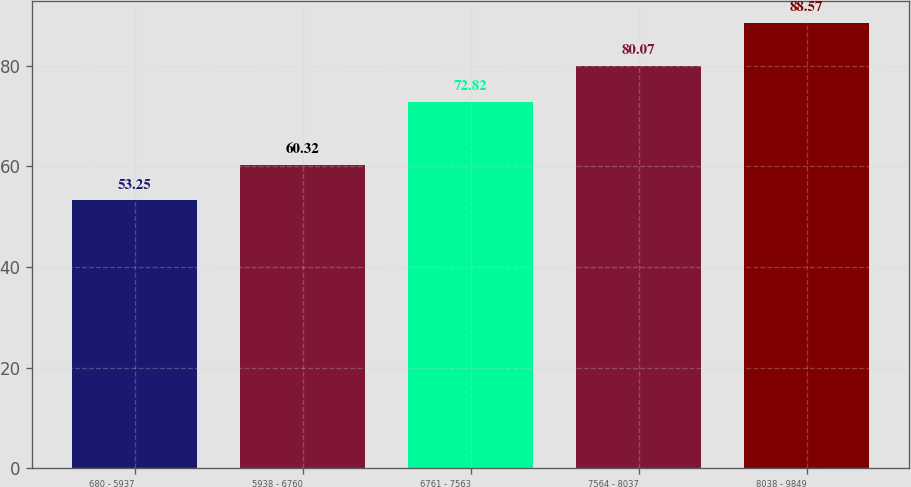Convert chart to OTSL. <chart><loc_0><loc_0><loc_500><loc_500><bar_chart><fcel>680 - 5937<fcel>5938 - 6760<fcel>6761 - 7563<fcel>7564 - 8037<fcel>8038 - 9849<nl><fcel>53.25<fcel>60.32<fcel>72.82<fcel>80.07<fcel>88.57<nl></chart> 